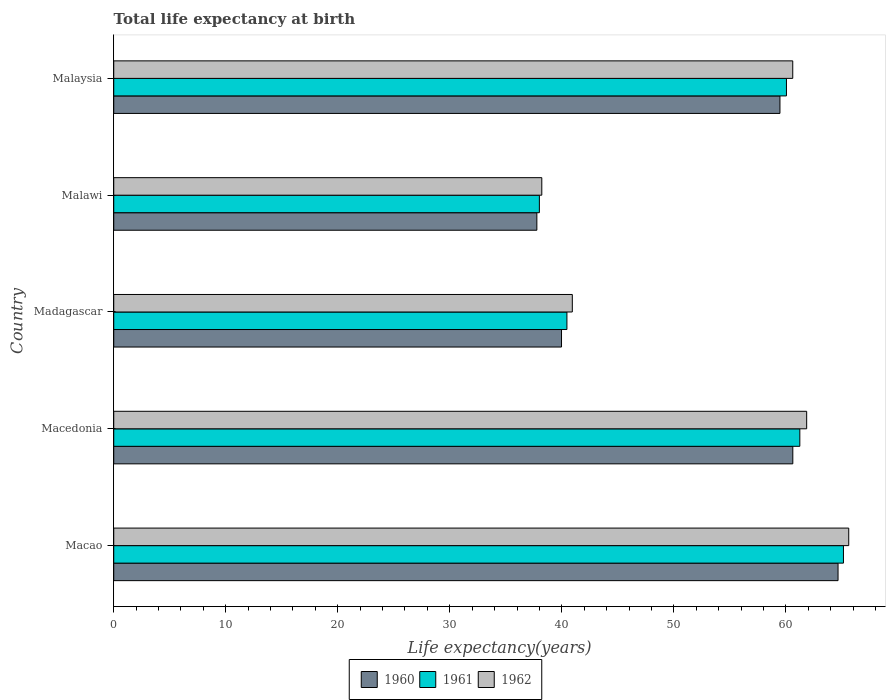How many different coloured bars are there?
Offer a terse response. 3. Are the number of bars per tick equal to the number of legend labels?
Provide a succinct answer. Yes. Are the number of bars on each tick of the Y-axis equal?
Provide a succinct answer. Yes. How many bars are there on the 5th tick from the top?
Provide a short and direct response. 3. How many bars are there on the 2nd tick from the bottom?
Offer a very short reply. 3. What is the label of the 3rd group of bars from the top?
Offer a very short reply. Madagascar. What is the life expectancy at birth in in 1962 in Malawi?
Your answer should be very brief. 38.21. Across all countries, what is the maximum life expectancy at birth in in 1961?
Keep it short and to the point. 65.14. Across all countries, what is the minimum life expectancy at birth in in 1960?
Offer a very short reply. 37.77. In which country was the life expectancy at birth in in 1962 maximum?
Keep it short and to the point. Macao. In which country was the life expectancy at birth in in 1962 minimum?
Your response must be concise. Malawi. What is the total life expectancy at birth in in 1962 in the graph?
Offer a very short reply. 267.24. What is the difference between the life expectancy at birth in in 1960 in Macao and that in Malawi?
Ensure brevity in your answer.  26.89. What is the difference between the life expectancy at birth in in 1961 in Macao and the life expectancy at birth in in 1960 in Malaysia?
Keep it short and to the point. 5.67. What is the average life expectancy at birth in in 1960 per country?
Keep it short and to the point. 52.5. What is the difference between the life expectancy at birth in in 1960 and life expectancy at birth in in 1961 in Macao?
Your answer should be very brief. -0.48. In how many countries, is the life expectancy at birth in in 1961 greater than 28 years?
Offer a very short reply. 5. What is the ratio of the life expectancy at birth in in 1960 in Macao to that in Madagascar?
Your answer should be very brief. 1.62. Is the difference between the life expectancy at birth in in 1960 in Madagascar and Malawi greater than the difference between the life expectancy at birth in in 1961 in Madagascar and Malawi?
Give a very brief answer. No. What is the difference between the highest and the second highest life expectancy at birth in in 1962?
Offer a very short reply. 3.76. What is the difference between the highest and the lowest life expectancy at birth in in 1961?
Offer a very short reply. 27.14. What does the 3rd bar from the top in Macao represents?
Your answer should be compact. 1960. Is it the case that in every country, the sum of the life expectancy at birth in in 1960 and life expectancy at birth in in 1961 is greater than the life expectancy at birth in in 1962?
Give a very brief answer. Yes. How many bars are there?
Provide a short and direct response. 15. How many countries are there in the graph?
Ensure brevity in your answer.  5. Does the graph contain grids?
Give a very brief answer. No. How are the legend labels stacked?
Offer a terse response. Horizontal. What is the title of the graph?
Your response must be concise. Total life expectancy at birth. What is the label or title of the X-axis?
Your answer should be very brief. Life expectancy(years). What is the label or title of the Y-axis?
Provide a succinct answer. Country. What is the Life expectancy(years) of 1960 in Macao?
Ensure brevity in your answer.  64.66. What is the Life expectancy(years) of 1961 in Macao?
Give a very brief answer. 65.14. What is the Life expectancy(years) of 1962 in Macao?
Keep it short and to the point. 65.62. What is the Life expectancy(years) of 1960 in Macedonia?
Make the answer very short. 60.62. What is the Life expectancy(years) in 1961 in Macedonia?
Your answer should be very brief. 61.25. What is the Life expectancy(years) in 1962 in Macedonia?
Your answer should be very brief. 61.86. What is the Life expectancy(years) of 1960 in Madagascar?
Offer a terse response. 39.97. What is the Life expectancy(years) in 1961 in Madagascar?
Your answer should be very brief. 40.46. What is the Life expectancy(years) of 1962 in Madagascar?
Your answer should be very brief. 40.94. What is the Life expectancy(years) in 1960 in Malawi?
Make the answer very short. 37.77. What is the Life expectancy(years) of 1961 in Malawi?
Provide a short and direct response. 38. What is the Life expectancy(years) of 1962 in Malawi?
Keep it short and to the point. 38.21. What is the Life expectancy(years) of 1960 in Malaysia?
Offer a very short reply. 59.48. What is the Life expectancy(years) of 1961 in Malaysia?
Your response must be concise. 60.05. What is the Life expectancy(years) of 1962 in Malaysia?
Your answer should be compact. 60.62. Across all countries, what is the maximum Life expectancy(years) of 1960?
Give a very brief answer. 64.66. Across all countries, what is the maximum Life expectancy(years) of 1961?
Provide a short and direct response. 65.14. Across all countries, what is the maximum Life expectancy(years) of 1962?
Offer a terse response. 65.62. Across all countries, what is the minimum Life expectancy(years) of 1960?
Your answer should be very brief. 37.77. Across all countries, what is the minimum Life expectancy(years) in 1961?
Provide a succinct answer. 38. Across all countries, what is the minimum Life expectancy(years) of 1962?
Offer a terse response. 38.21. What is the total Life expectancy(years) in 1960 in the graph?
Provide a short and direct response. 262.51. What is the total Life expectancy(years) in 1961 in the graph?
Provide a succinct answer. 264.9. What is the total Life expectancy(years) in 1962 in the graph?
Your response must be concise. 267.24. What is the difference between the Life expectancy(years) of 1960 in Macao and that in Macedonia?
Your response must be concise. 4.04. What is the difference between the Life expectancy(years) in 1961 in Macao and that in Macedonia?
Offer a very short reply. 3.89. What is the difference between the Life expectancy(years) in 1962 in Macao and that in Macedonia?
Your answer should be compact. 3.76. What is the difference between the Life expectancy(years) of 1960 in Macao and that in Madagascar?
Ensure brevity in your answer.  24.69. What is the difference between the Life expectancy(years) in 1961 in Macao and that in Madagascar?
Make the answer very short. 24.69. What is the difference between the Life expectancy(years) of 1962 in Macao and that in Madagascar?
Give a very brief answer. 24.68. What is the difference between the Life expectancy(years) of 1960 in Macao and that in Malawi?
Your answer should be very brief. 26.89. What is the difference between the Life expectancy(years) in 1961 in Macao and that in Malawi?
Offer a terse response. 27.14. What is the difference between the Life expectancy(years) in 1962 in Macao and that in Malawi?
Your answer should be compact. 27.4. What is the difference between the Life expectancy(years) of 1960 in Macao and that in Malaysia?
Your answer should be compact. 5.19. What is the difference between the Life expectancy(years) in 1961 in Macao and that in Malaysia?
Your response must be concise. 5.09. What is the difference between the Life expectancy(years) in 1962 in Macao and that in Malaysia?
Offer a terse response. 5. What is the difference between the Life expectancy(years) in 1960 in Macedonia and that in Madagascar?
Your answer should be very brief. 20.65. What is the difference between the Life expectancy(years) of 1961 in Macedonia and that in Madagascar?
Provide a succinct answer. 20.79. What is the difference between the Life expectancy(years) in 1962 in Macedonia and that in Madagascar?
Your response must be concise. 20.92. What is the difference between the Life expectancy(years) of 1960 in Macedonia and that in Malawi?
Make the answer very short. 22.85. What is the difference between the Life expectancy(years) in 1961 in Macedonia and that in Malawi?
Provide a short and direct response. 23.25. What is the difference between the Life expectancy(years) in 1962 in Macedonia and that in Malawi?
Provide a short and direct response. 23.65. What is the difference between the Life expectancy(years) of 1960 in Macedonia and that in Malaysia?
Make the answer very short. 1.15. What is the difference between the Life expectancy(years) of 1961 in Macedonia and that in Malaysia?
Your response must be concise. 1.2. What is the difference between the Life expectancy(years) of 1962 in Macedonia and that in Malaysia?
Ensure brevity in your answer.  1.24. What is the difference between the Life expectancy(years) of 1960 in Madagascar and that in Malawi?
Provide a short and direct response. 2.2. What is the difference between the Life expectancy(years) of 1961 in Madagascar and that in Malawi?
Keep it short and to the point. 2.46. What is the difference between the Life expectancy(years) in 1962 in Madagascar and that in Malawi?
Your response must be concise. 2.72. What is the difference between the Life expectancy(years) of 1960 in Madagascar and that in Malaysia?
Keep it short and to the point. -19.5. What is the difference between the Life expectancy(years) of 1961 in Madagascar and that in Malaysia?
Your response must be concise. -19.6. What is the difference between the Life expectancy(years) of 1962 in Madagascar and that in Malaysia?
Ensure brevity in your answer.  -19.68. What is the difference between the Life expectancy(years) of 1960 in Malawi and that in Malaysia?
Provide a short and direct response. -21.7. What is the difference between the Life expectancy(years) in 1961 in Malawi and that in Malaysia?
Your answer should be compact. -22.06. What is the difference between the Life expectancy(years) in 1962 in Malawi and that in Malaysia?
Your answer should be very brief. -22.4. What is the difference between the Life expectancy(years) of 1960 in Macao and the Life expectancy(years) of 1961 in Macedonia?
Offer a very short reply. 3.41. What is the difference between the Life expectancy(years) of 1960 in Macao and the Life expectancy(years) of 1962 in Macedonia?
Make the answer very short. 2.8. What is the difference between the Life expectancy(years) in 1961 in Macao and the Life expectancy(years) in 1962 in Macedonia?
Provide a succinct answer. 3.28. What is the difference between the Life expectancy(years) in 1960 in Macao and the Life expectancy(years) in 1961 in Madagascar?
Offer a terse response. 24.2. What is the difference between the Life expectancy(years) of 1960 in Macao and the Life expectancy(years) of 1962 in Madagascar?
Offer a terse response. 23.72. What is the difference between the Life expectancy(years) in 1961 in Macao and the Life expectancy(years) in 1962 in Madagascar?
Offer a very short reply. 24.21. What is the difference between the Life expectancy(years) of 1960 in Macao and the Life expectancy(years) of 1961 in Malawi?
Make the answer very short. 26.66. What is the difference between the Life expectancy(years) of 1960 in Macao and the Life expectancy(years) of 1962 in Malawi?
Provide a short and direct response. 26.45. What is the difference between the Life expectancy(years) in 1961 in Macao and the Life expectancy(years) in 1962 in Malawi?
Ensure brevity in your answer.  26.93. What is the difference between the Life expectancy(years) in 1960 in Macao and the Life expectancy(years) in 1961 in Malaysia?
Provide a succinct answer. 4.61. What is the difference between the Life expectancy(years) in 1960 in Macao and the Life expectancy(years) in 1962 in Malaysia?
Provide a succinct answer. 4.04. What is the difference between the Life expectancy(years) in 1961 in Macao and the Life expectancy(years) in 1962 in Malaysia?
Provide a succinct answer. 4.53. What is the difference between the Life expectancy(years) in 1960 in Macedonia and the Life expectancy(years) in 1961 in Madagascar?
Provide a succinct answer. 20.17. What is the difference between the Life expectancy(years) of 1960 in Macedonia and the Life expectancy(years) of 1962 in Madagascar?
Your answer should be compact. 19.68. What is the difference between the Life expectancy(years) of 1961 in Macedonia and the Life expectancy(years) of 1962 in Madagascar?
Keep it short and to the point. 20.31. What is the difference between the Life expectancy(years) in 1960 in Macedonia and the Life expectancy(years) in 1961 in Malawi?
Your response must be concise. 22.62. What is the difference between the Life expectancy(years) of 1960 in Macedonia and the Life expectancy(years) of 1962 in Malawi?
Give a very brief answer. 22.41. What is the difference between the Life expectancy(years) of 1961 in Macedonia and the Life expectancy(years) of 1962 in Malawi?
Your answer should be compact. 23.04. What is the difference between the Life expectancy(years) of 1960 in Macedonia and the Life expectancy(years) of 1961 in Malaysia?
Your answer should be very brief. 0.57. What is the difference between the Life expectancy(years) of 1960 in Macedonia and the Life expectancy(years) of 1962 in Malaysia?
Your response must be concise. 0.01. What is the difference between the Life expectancy(years) of 1961 in Macedonia and the Life expectancy(years) of 1962 in Malaysia?
Your response must be concise. 0.63. What is the difference between the Life expectancy(years) of 1960 in Madagascar and the Life expectancy(years) of 1961 in Malawi?
Offer a terse response. 1.98. What is the difference between the Life expectancy(years) of 1960 in Madagascar and the Life expectancy(years) of 1962 in Malawi?
Your answer should be compact. 1.76. What is the difference between the Life expectancy(years) in 1961 in Madagascar and the Life expectancy(years) in 1962 in Malawi?
Provide a short and direct response. 2.24. What is the difference between the Life expectancy(years) of 1960 in Madagascar and the Life expectancy(years) of 1961 in Malaysia?
Keep it short and to the point. -20.08. What is the difference between the Life expectancy(years) of 1960 in Madagascar and the Life expectancy(years) of 1962 in Malaysia?
Offer a very short reply. -20.64. What is the difference between the Life expectancy(years) in 1961 in Madagascar and the Life expectancy(years) in 1962 in Malaysia?
Your response must be concise. -20.16. What is the difference between the Life expectancy(years) in 1960 in Malawi and the Life expectancy(years) in 1961 in Malaysia?
Give a very brief answer. -22.28. What is the difference between the Life expectancy(years) in 1960 in Malawi and the Life expectancy(years) in 1962 in Malaysia?
Provide a short and direct response. -22.84. What is the difference between the Life expectancy(years) in 1961 in Malawi and the Life expectancy(years) in 1962 in Malaysia?
Offer a terse response. -22.62. What is the average Life expectancy(years) of 1960 per country?
Provide a succinct answer. 52.5. What is the average Life expectancy(years) in 1961 per country?
Your response must be concise. 52.98. What is the average Life expectancy(years) in 1962 per country?
Make the answer very short. 53.45. What is the difference between the Life expectancy(years) in 1960 and Life expectancy(years) in 1961 in Macao?
Provide a short and direct response. -0.48. What is the difference between the Life expectancy(years) in 1960 and Life expectancy(years) in 1962 in Macao?
Offer a terse response. -0.95. What is the difference between the Life expectancy(years) of 1961 and Life expectancy(years) of 1962 in Macao?
Your answer should be compact. -0.47. What is the difference between the Life expectancy(years) of 1960 and Life expectancy(years) of 1961 in Macedonia?
Your answer should be compact. -0.63. What is the difference between the Life expectancy(years) of 1960 and Life expectancy(years) of 1962 in Macedonia?
Your response must be concise. -1.24. What is the difference between the Life expectancy(years) in 1961 and Life expectancy(years) in 1962 in Macedonia?
Ensure brevity in your answer.  -0.61. What is the difference between the Life expectancy(years) in 1960 and Life expectancy(years) in 1961 in Madagascar?
Give a very brief answer. -0.48. What is the difference between the Life expectancy(years) of 1960 and Life expectancy(years) of 1962 in Madagascar?
Provide a short and direct response. -0.96. What is the difference between the Life expectancy(years) of 1961 and Life expectancy(years) of 1962 in Madagascar?
Your response must be concise. -0.48. What is the difference between the Life expectancy(years) in 1960 and Life expectancy(years) in 1961 in Malawi?
Your answer should be compact. -0.22. What is the difference between the Life expectancy(years) in 1960 and Life expectancy(years) in 1962 in Malawi?
Your response must be concise. -0.44. What is the difference between the Life expectancy(years) in 1961 and Life expectancy(years) in 1962 in Malawi?
Keep it short and to the point. -0.22. What is the difference between the Life expectancy(years) of 1960 and Life expectancy(years) of 1961 in Malaysia?
Provide a short and direct response. -0.58. What is the difference between the Life expectancy(years) of 1960 and Life expectancy(years) of 1962 in Malaysia?
Your answer should be compact. -1.14. What is the difference between the Life expectancy(years) of 1961 and Life expectancy(years) of 1962 in Malaysia?
Offer a terse response. -0.56. What is the ratio of the Life expectancy(years) in 1960 in Macao to that in Macedonia?
Give a very brief answer. 1.07. What is the ratio of the Life expectancy(years) in 1961 in Macao to that in Macedonia?
Offer a terse response. 1.06. What is the ratio of the Life expectancy(years) in 1962 in Macao to that in Macedonia?
Keep it short and to the point. 1.06. What is the ratio of the Life expectancy(years) in 1960 in Macao to that in Madagascar?
Provide a succinct answer. 1.62. What is the ratio of the Life expectancy(years) in 1961 in Macao to that in Madagascar?
Ensure brevity in your answer.  1.61. What is the ratio of the Life expectancy(years) in 1962 in Macao to that in Madagascar?
Ensure brevity in your answer.  1.6. What is the ratio of the Life expectancy(years) of 1960 in Macao to that in Malawi?
Offer a terse response. 1.71. What is the ratio of the Life expectancy(years) of 1961 in Macao to that in Malawi?
Your answer should be compact. 1.71. What is the ratio of the Life expectancy(years) of 1962 in Macao to that in Malawi?
Your answer should be compact. 1.72. What is the ratio of the Life expectancy(years) of 1960 in Macao to that in Malaysia?
Keep it short and to the point. 1.09. What is the ratio of the Life expectancy(years) in 1961 in Macao to that in Malaysia?
Give a very brief answer. 1.08. What is the ratio of the Life expectancy(years) in 1962 in Macao to that in Malaysia?
Your response must be concise. 1.08. What is the ratio of the Life expectancy(years) of 1960 in Macedonia to that in Madagascar?
Offer a very short reply. 1.52. What is the ratio of the Life expectancy(years) in 1961 in Macedonia to that in Madagascar?
Your answer should be very brief. 1.51. What is the ratio of the Life expectancy(years) in 1962 in Macedonia to that in Madagascar?
Your response must be concise. 1.51. What is the ratio of the Life expectancy(years) of 1960 in Macedonia to that in Malawi?
Ensure brevity in your answer.  1.6. What is the ratio of the Life expectancy(years) of 1961 in Macedonia to that in Malawi?
Your answer should be very brief. 1.61. What is the ratio of the Life expectancy(years) of 1962 in Macedonia to that in Malawi?
Ensure brevity in your answer.  1.62. What is the ratio of the Life expectancy(years) of 1960 in Macedonia to that in Malaysia?
Make the answer very short. 1.02. What is the ratio of the Life expectancy(years) in 1961 in Macedonia to that in Malaysia?
Your answer should be very brief. 1.02. What is the ratio of the Life expectancy(years) in 1962 in Macedonia to that in Malaysia?
Provide a short and direct response. 1.02. What is the ratio of the Life expectancy(years) of 1960 in Madagascar to that in Malawi?
Make the answer very short. 1.06. What is the ratio of the Life expectancy(years) in 1961 in Madagascar to that in Malawi?
Keep it short and to the point. 1.06. What is the ratio of the Life expectancy(years) in 1962 in Madagascar to that in Malawi?
Provide a short and direct response. 1.07. What is the ratio of the Life expectancy(years) of 1960 in Madagascar to that in Malaysia?
Give a very brief answer. 0.67. What is the ratio of the Life expectancy(years) of 1961 in Madagascar to that in Malaysia?
Keep it short and to the point. 0.67. What is the ratio of the Life expectancy(years) of 1962 in Madagascar to that in Malaysia?
Offer a terse response. 0.68. What is the ratio of the Life expectancy(years) in 1960 in Malawi to that in Malaysia?
Offer a terse response. 0.64. What is the ratio of the Life expectancy(years) of 1961 in Malawi to that in Malaysia?
Make the answer very short. 0.63. What is the ratio of the Life expectancy(years) in 1962 in Malawi to that in Malaysia?
Provide a succinct answer. 0.63. What is the difference between the highest and the second highest Life expectancy(years) of 1960?
Your response must be concise. 4.04. What is the difference between the highest and the second highest Life expectancy(years) of 1961?
Offer a terse response. 3.89. What is the difference between the highest and the second highest Life expectancy(years) in 1962?
Your answer should be very brief. 3.76. What is the difference between the highest and the lowest Life expectancy(years) of 1960?
Your answer should be compact. 26.89. What is the difference between the highest and the lowest Life expectancy(years) in 1961?
Offer a terse response. 27.14. What is the difference between the highest and the lowest Life expectancy(years) in 1962?
Keep it short and to the point. 27.4. 